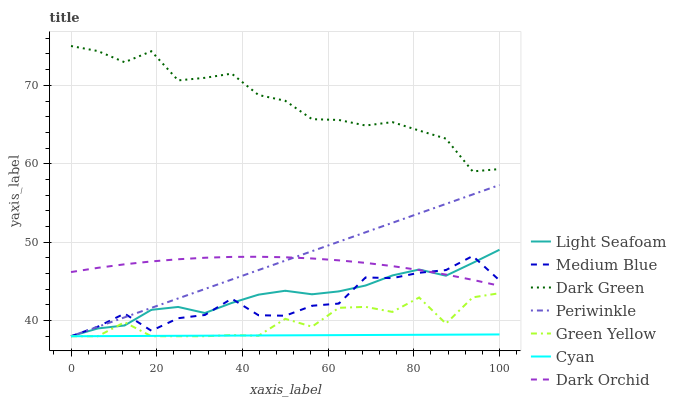Does Cyan have the minimum area under the curve?
Answer yes or no. Yes. Does Dark Green have the maximum area under the curve?
Answer yes or no. Yes. Does Medium Blue have the minimum area under the curve?
Answer yes or no. No. Does Medium Blue have the maximum area under the curve?
Answer yes or no. No. Is Periwinkle the smoothest?
Answer yes or no. Yes. Is Green Yellow the roughest?
Answer yes or no. Yes. Is Medium Blue the smoothest?
Answer yes or no. No. Is Medium Blue the roughest?
Answer yes or no. No. Does Light Seafoam have the lowest value?
Answer yes or no. Yes. Does Dark Orchid have the lowest value?
Answer yes or no. No. Does Dark Green have the highest value?
Answer yes or no. Yes. Does Medium Blue have the highest value?
Answer yes or no. No. Is Light Seafoam less than Dark Green?
Answer yes or no. Yes. Is Dark Orchid greater than Green Yellow?
Answer yes or no. Yes. Does Periwinkle intersect Green Yellow?
Answer yes or no. Yes. Is Periwinkle less than Green Yellow?
Answer yes or no. No. Is Periwinkle greater than Green Yellow?
Answer yes or no. No. Does Light Seafoam intersect Dark Green?
Answer yes or no. No. 